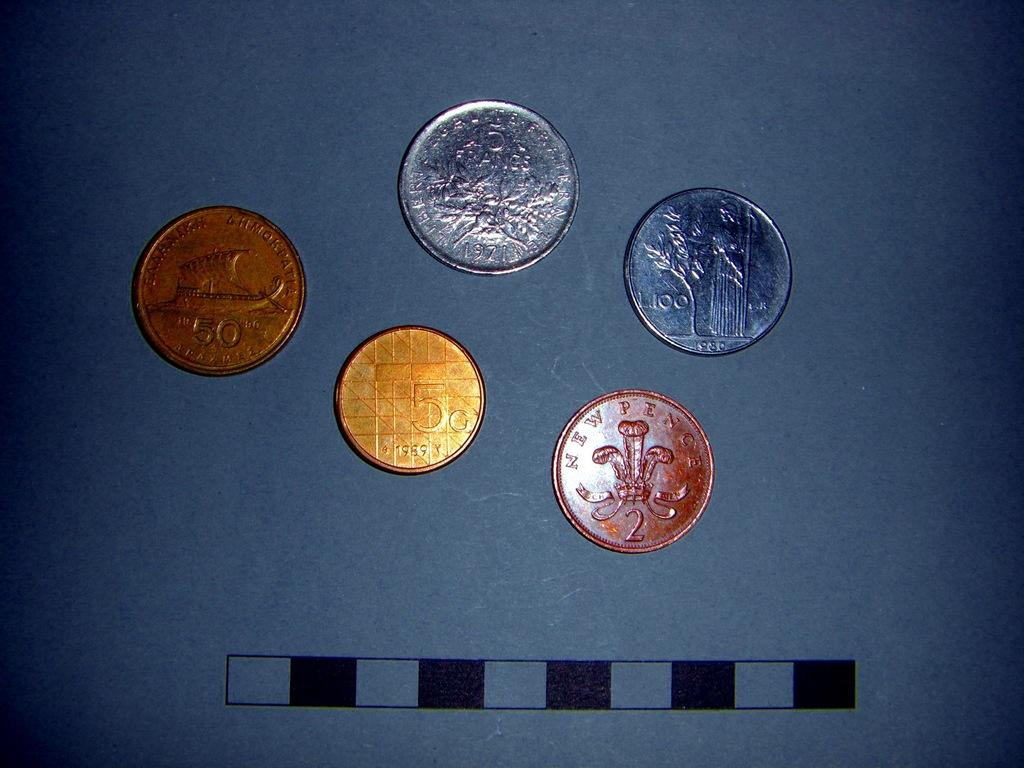<image>
Create a compact narrative representing the image presented. Four coins next to one another with the gold one having a number 5 on it. 